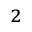Convert formula to latex. <formula><loc_0><loc_0><loc_500><loc_500>_ { 2 }</formula> 